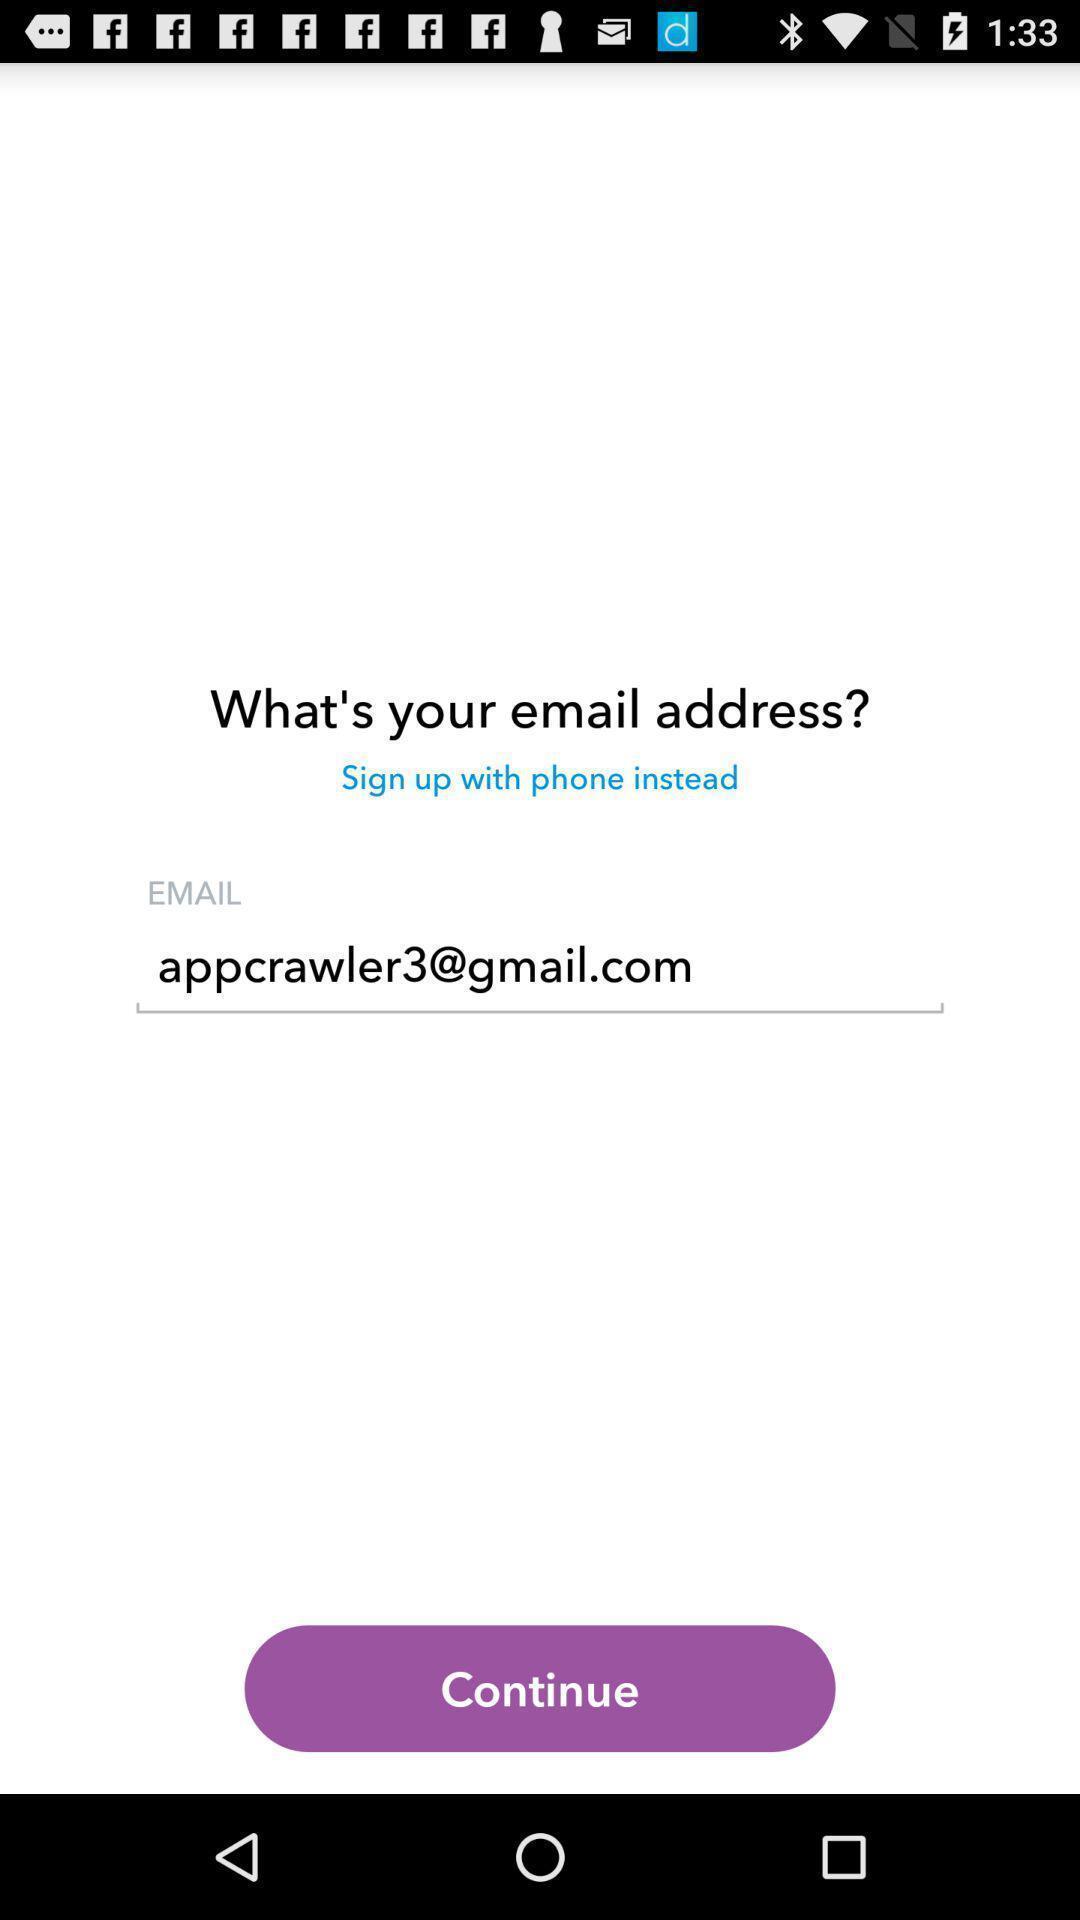Please provide a description for this image. Sign up page. 